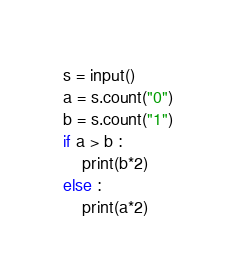<code> <loc_0><loc_0><loc_500><loc_500><_Python_>s = input()
a = s.count("0")
b = s.count("1")
if a > b :
    print(b*2)
else :
    print(a*2)
</code> 